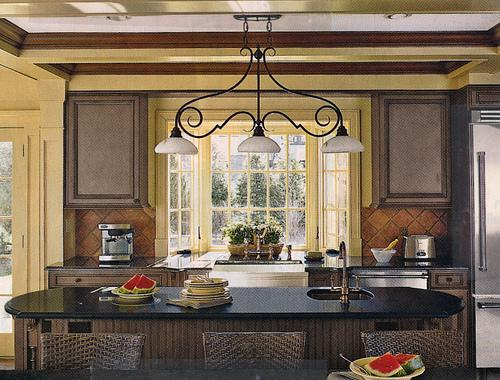In which one of these months do people like to eat this fruit?

Choices:
A) december
B) july
C) october
D) april july 